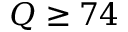<formula> <loc_0><loc_0><loc_500><loc_500>Q \geq 7 4</formula> 